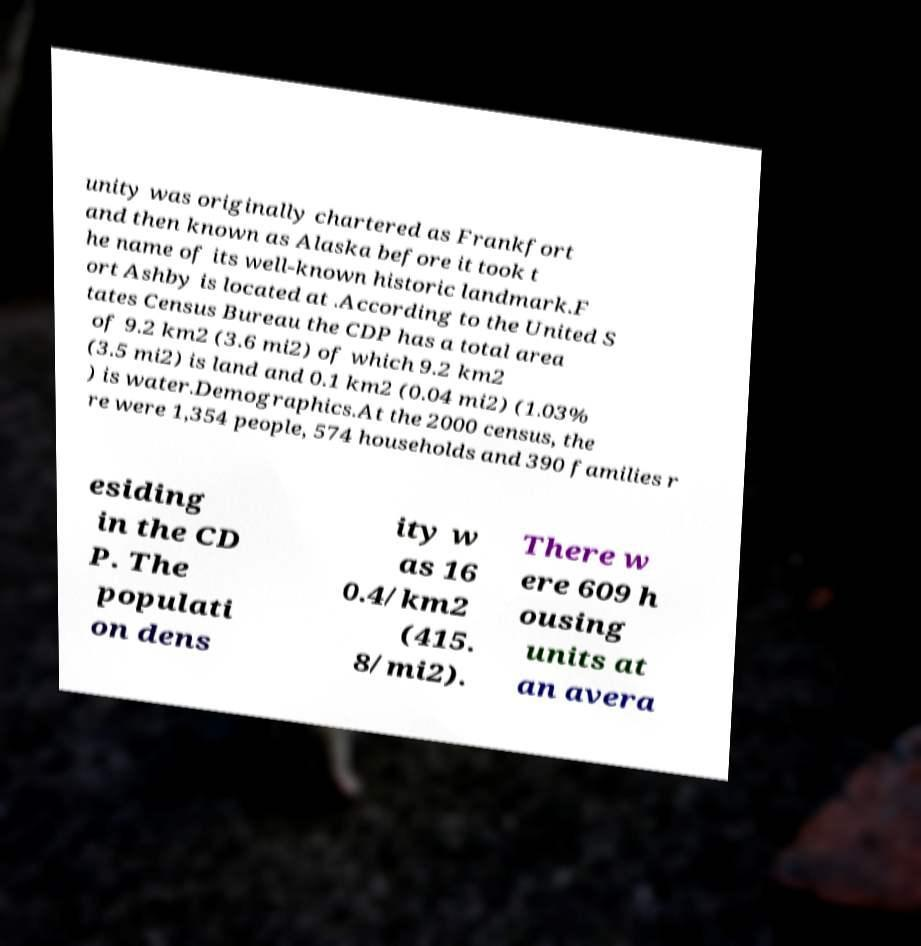Could you extract and type out the text from this image? unity was originally chartered as Frankfort and then known as Alaska before it took t he name of its well-known historic landmark.F ort Ashby is located at .According to the United S tates Census Bureau the CDP has a total area of 9.2 km2 (3.6 mi2) of which 9.2 km2 (3.5 mi2) is land and 0.1 km2 (0.04 mi2) (1.03% ) is water.Demographics.At the 2000 census, the re were 1,354 people, 574 households and 390 families r esiding in the CD P. The populati on dens ity w as 16 0.4/km2 (415. 8/mi2). There w ere 609 h ousing units at an avera 